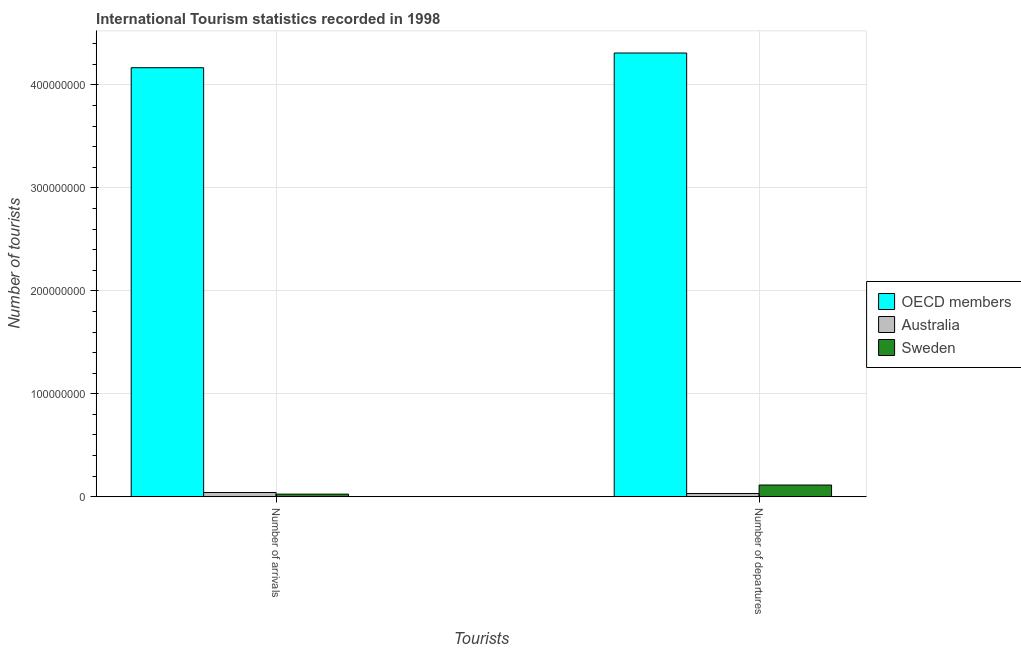How many groups of bars are there?
Provide a succinct answer. 2. Are the number of bars per tick equal to the number of legend labels?
Offer a terse response. Yes. How many bars are there on the 2nd tick from the left?
Offer a very short reply. 3. How many bars are there on the 1st tick from the right?
Keep it short and to the point. 3. What is the label of the 2nd group of bars from the left?
Offer a very short reply. Number of departures. What is the number of tourist arrivals in Sweden?
Keep it short and to the point. 2.57e+06. Across all countries, what is the maximum number of tourist arrivals?
Make the answer very short. 4.17e+08. Across all countries, what is the minimum number of tourist departures?
Your response must be concise. 3.16e+06. In which country was the number of tourist departures minimum?
Your response must be concise. Australia. What is the total number of tourist departures in the graph?
Your answer should be compact. 4.45e+08. What is the difference between the number of tourist arrivals in OECD members and that in Australia?
Keep it short and to the point. 4.12e+08. What is the difference between the number of tourist arrivals in Sweden and the number of tourist departures in OECD members?
Ensure brevity in your answer.  -4.28e+08. What is the average number of tourist arrivals per country?
Your response must be concise. 1.41e+08. What is the difference between the number of tourist arrivals and number of tourist departures in Australia?
Your answer should be compact. 1.01e+06. What is the ratio of the number of tourist arrivals in Australia to that in OECD members?
Offer a terse response. 0.01. What does the 1st bar from the left in Number of departures represents?
Your answer should be very brief. OECD members. What does the 3rd bar from the right in Number of departures represents?
Your answer should be compact. OECD members. How many bars are there?
Offer a very short reply. 6. How many countries are there in the graph?
Provide a short and direct response. 3. Are the values on the major ticks of Y-axis written in scientific E-notation?
Give a very brief answer. No. Does the graph contain any zero values?
Give a very brief answer. No. Where does the legend appear in the graph?
Give a very brief answer. Center right. What is the title of the graph?
Your answer should be compact. International Tourism statistics recorded in 1998. What is the label or title of the X-axis?
Ensure brevity in your answer.  Tourists. What is the label or title of the Y-axis?
Offer a terse response. Number of tourists. What is the Number of tourists in OECD members in Number of arrivals?
Provide a short and direct response. 4.17e+08. What is the Number of tourists of Australia in Number of arrivals?
Give a very brief answer. 4.17e+06. What is the Number of tourists of Sweden in Number of arrivals?
Ensure brevity in your answer.  2.57e+06. What is the Number of tourists in OECD members in Number of departures?
Offer a very short reply. 4.31e+08. What is the Number of tourists in Australia in Number of departures?
Offer a terse response. 3.16e+06. What is the Number of tourists of Sweden in Number of departures?
Your response must be concise. 1.14e+07. Across all Tourists, what is the maximum Number of tourists in OECD members?
Offer a very short reply. 4.31e+08. Across all Tourists, what is the maximum Number of tourists in Australia?
Your response must be concise. 4.17e+06. Across all Tourists, what is the maximum Number of tourists in Sweden?
Your answer should be compact. 1.14e+07. Across all Tourists, what is the minimum Number of tourists of OECD members?
Provide a succinct answer. 4.17e+08. Across all Tourists, what is the minimum Number of tourists of Australia?
Your response must be concise. 3.16e+06. Across all Tourists, what is the minimum Number of tourists in Sweden?
Make the answer very short. 2.57e+06. What is the total Number of tourists in OECD members in the graph?
Your answer should be very brief. 8.48e+08. What is the total Number of tourists in Australia in the graph?
Make the answer very short. 7.33e+06. What is the total Number of tourists in Sweden in the graph?
Your answer should be compact. 1.40e+07. What is the difference between the Number of tourists of OECD members in Number of arrivals and that in Number of departures?
Ensure brevity in your answer.  -1.43e+07. What is the difference between the Number of tourists in Australia in Number of arrivals and that in Number of departures?
Give a very brief answer. 1.01e+06. What is the difference between the Number of tourists in Sweden in Number of arrivals and that in Number of departures?
Ensure brevity in your answer.  -8.85e+06. What is the difference between the Number of tourists in OECD members in Number of arrivals and the Number of tourists in Australia in Number of departures?
Your answer should be very brief. 4.13e+08. What is the difference between the Number of tourists in OECD members in Number of arrivals and the Number of tourists in Sweden in Number of departures?
Make the answer very short. 4.05e+08. What is the difference between the Number of tourists in Australia in Number of arrivals and the Number of tourists in Sweden in Number of departures?
Ensure brevity in your answer.  -7.26e+06. What is the average Number of tourists in OECD members per Tourists?
Offer a very short reply. 4.24e+08. What is the average Number of tourists in Australia per Tourists?
Provide a succinct answer. 3.66e+06. What is the average Number of tourists in Sweden per Tourists?
Your answer should be compact. 7.00e+06. What is the difference between the Number of tourists of OECD members and Number of tourists of Australia in Number of arrivals?
Offer a terse response. 4.12e+08. What is the difference between the Number of tourists of OECD members and Number of tourists of Sweden in Number of arrivals?
Your answer should be very brief. 4.14e+08. What is the difference between the Number of tourists in Australia and Number of tourists in Sweden in Number of arrivals?
Give a very brief answer. 1.59e+06. What is the difference between the Number of tourists of OECD members and Number of tourists of Australia in Number of departures?
Offer a very short reply. 4.28e+08. What is the difference between the Number of tourists of OECD members and Number of tourists of Sweden in Number of departures?
Ensure brevity in your answer.  4.19e+08. What is the difference between the Number of tourists of Australia and Number of tourists of Sweden in Number of departures?
Give a very brief answer. -8.26e+06. What is the ratio of the Number of tourists of OECD members in Number of arrivals to that in Number of departures?
Give a very brief answer. 0.97. What is the ratio of the Number of tourists in Australia in Number of arrivals to that in Number of departures?
Give a very brief answer. 1.32. What is the ratio of the Number of tourists of Sweden in Number of arrivals to that in Number of departures?
Provide a short and direct response. 0.23. What is the difference between the highest and the second highest Number of tourists in OECD members?
Make the answer very short. 1.43e+07. What is the difference between the highest and the second highest Number of tourists of Australia?
Keep it short and to the point. 1.01e+06. What is the difference between the highest and the second highest Number of tourists in Sweden?
Your answer should be compact. 8.85e+06. What is the difference between the highest and the lowest Number of tourists of OECD members?
Your answer should be very brief. 1.43e+07. What is the difference between the highest and the lowest Number of tourists in Australia?
Ensure brevity in your answer.  1.01e+06. What is the difference between the highest and the lowest Number of tourists of Sweden?
Offer a very short reply. 8.85e+06. 